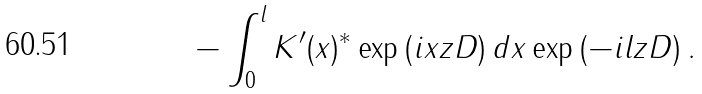Convert formula to latex. <formula><loc_0><loc_0><loc_500><loc_500>- \int _ { 0 } ^ { l } K ^ { \prime } ( x ) ^ { * } \exp \left ( i x z D \right ) d x \exp \left ( - i l z D \right ) .</formula> 